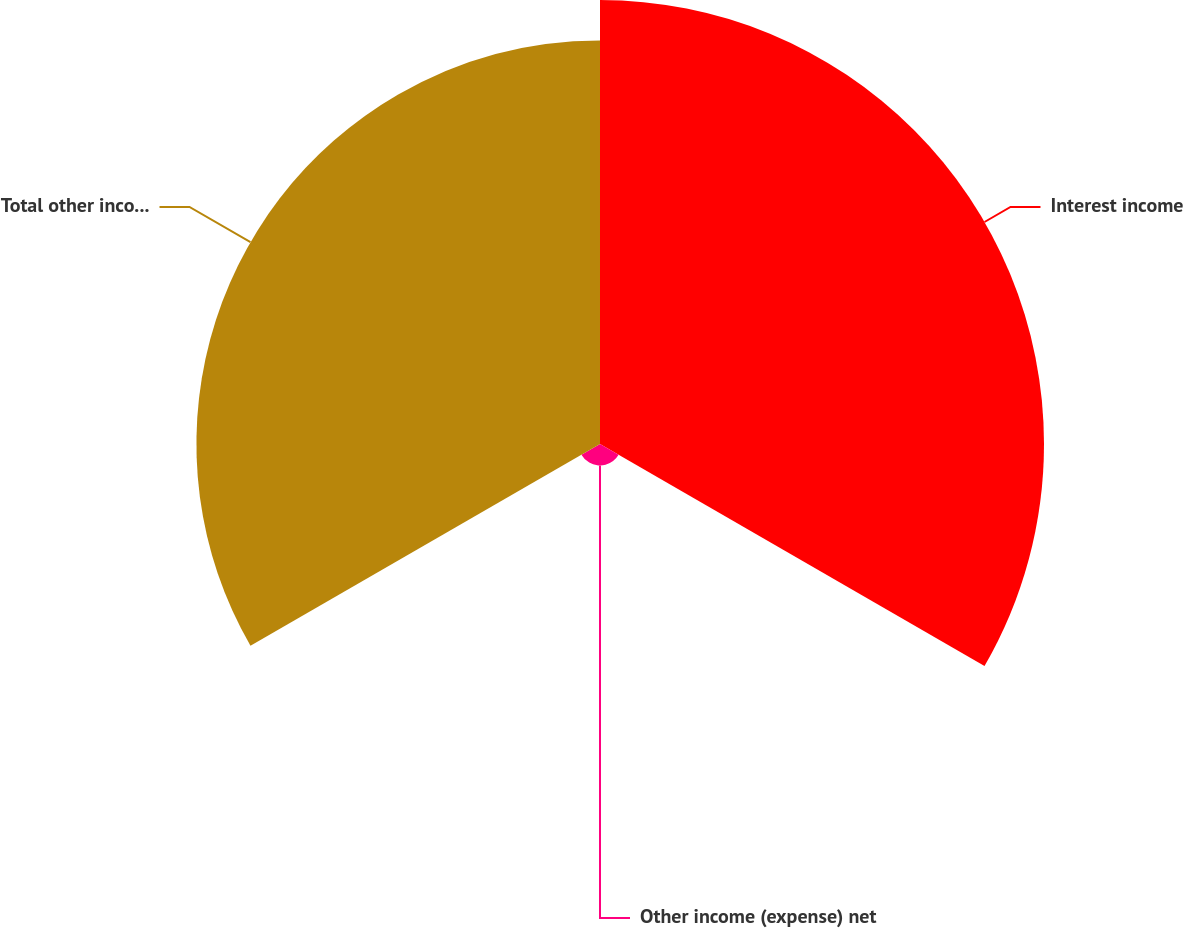Convert chart to OTSL. <chart><loc_0><loc_0><loc_500><loc_500><pie_chart><fcel>Interest income<fcel>Other income (expense) net<fcel>Total other income and expense<nl><fcel>51.09%<fcel>2.47%<fcel>46.44%<nl></chart> 